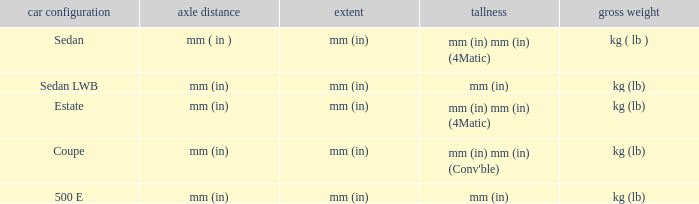What's the length of the model with Sedan body style? Mm (in). 